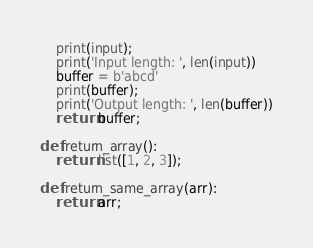<code> <loc_0><loc_0><loc_500><loc_500><_Python_>	print(input);
	print('Input length: ', len(input))
	buffer = b'abcd'
	print(buffer);
	print('Output length: ', len(buffer))
	return buffer;

def return_array():
	return list([1, 2, 3]);

def return_same_array(arr):
	return arr;
</code> 